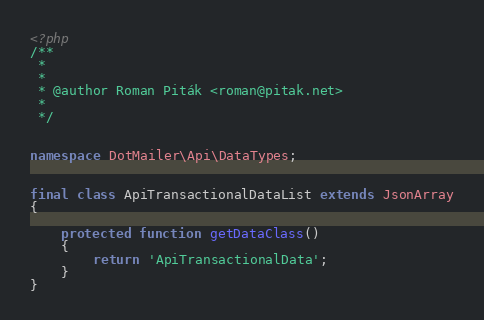Convert code to text. <code><loc_0><loc_0><loc_500><loc_500><_PHP_><?php
/**
 *
 *
 * @author Roman Piták <roman@pitak.net>
 *
 */


namespace DotMailer\Api\DataTypes;


final class ApiTransactionalDataList extends JsonArray
{

    protected function getDataClass()
    {
        return 'ApiTransactionalData';
    }
}
</code> 